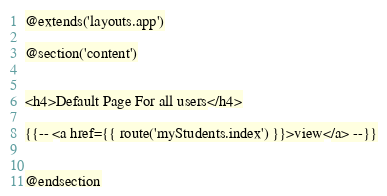Convert code to text. <code><loc_0><loc_0><loc_500><loc_500><_PHP_>@extends('layouts.app')

@section('content')


<h4>Default Page For all users</h4>

{{-- <a href={{ route('myStudents.index') }}>view</a> --}}


@endsection</code> 